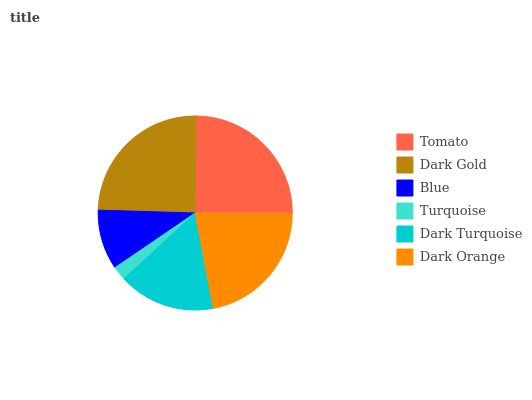Is Turquoise the minimum?
Answer yes or no. Yes. Is Tomato the maximum?
Answer yes or no. Yes. Is Dark Gold the minimum?
Answer yes or no. No. Is Dark Gold the maximum?
Answer yes or no. No. Is Tomato greater than Dark Gold?
Answer yes or no. Yes. Is Dark Gold less than Tomato?
Answer yes or no. Yes. Is Dark Gold greater than Tomato?
Answer yes or no. No. Is Tomato less than Dark Gold?
Answer yes or no. No. Is Dark Orange the high median?
Answer yes or no. Yes. Is Dark Turquoise the low median?
Answer yes or no. Yes. Is Dark Gold the high median?
Answer yes or no. No. Is Blue the low median?
Answer yes or no. No. 